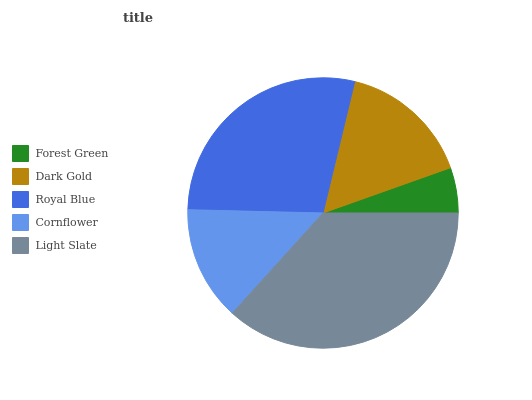Is Forest Green the minimum?
Answer yes or no. Yes. Is Light Slate the maximum?
Answer yes or no. Yes. Is Dark Gold the minimum?
Answer yes or no. No. Is Dark Gold the maximum?
Answer yes or no. No. Is Dark Gold greater than Forest Green?
Answer yes or no. Yes. Is Forest Green less than Dark Gold?
Answer yes or no. Yes. Is Forest Green greater than Dark Gold?
Answer yes or no. No. Is Dark Gold less than Forest Green?
Answer yes or no. No. Is Dark Gold the high median?
Answer yes or no. Yes. Is Dark Gold the low median?
Answer yes or no. Yes. Is Royal Blue the high median?
Answer yes or no. No. Is Light Slate the low median?
Answer yes or no. No. 